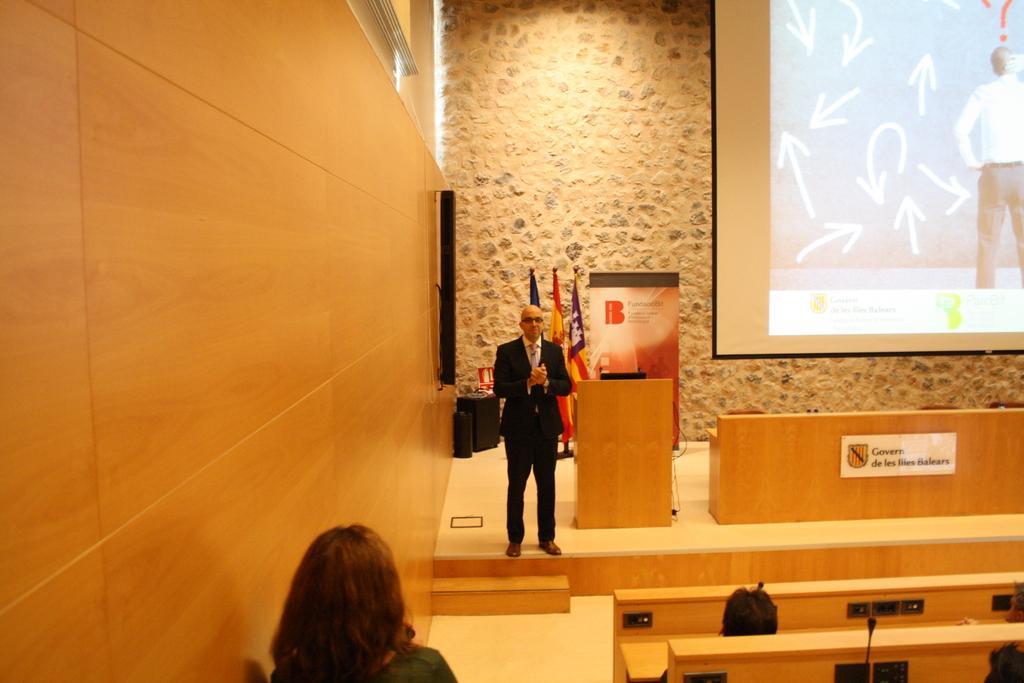In one or two sentences, can you explain what this image depicts? In the picture I can see this person on the left side of the image, here I can see wooden benches, mics and this person wearing black color blazer is standing on the stage, here I can see a podium, a board to the wooden table, I can see a banner, some objects, flags, wooden wall, stone wall and projector on which something is displayed in the background. 